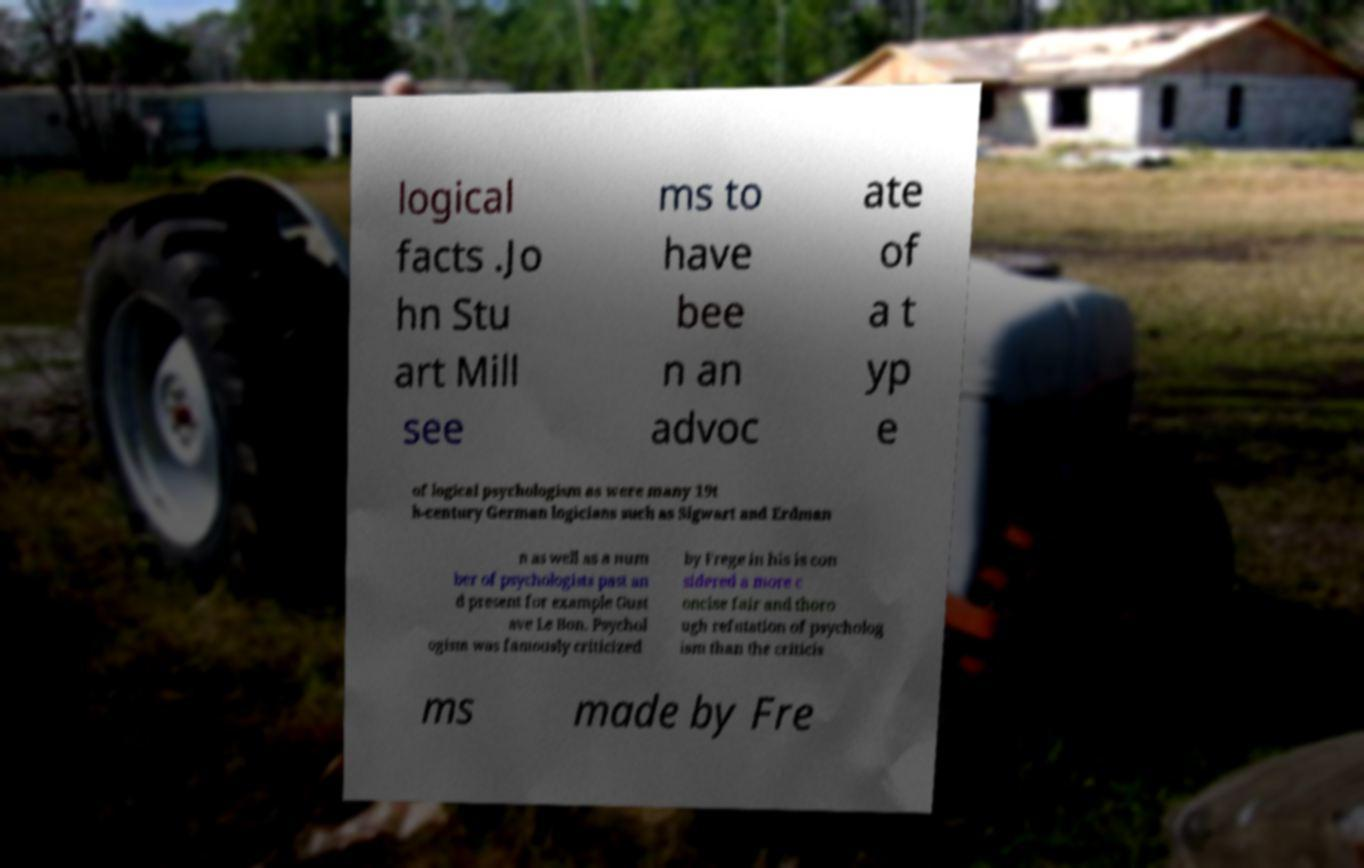There's text embedded in this image that I need extracted. Can you transcribe it verbatim? logical facts .Jo hn Stu art Mill see ms to have bee n an advoc ate of a t yp e of logical psychologism as were many 19t h-century German logicians such as Sigwart and Erdman n as well as a num ber of psychologists past an d present for example Gust ave Le Bon. Psychol ogism was famously criticized by Frege in his is con sidered a more c oncise fair and thoro ugh refutation of psycholog ism than the criticis ms made by Fre 